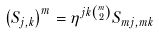Convert formula to latex. <formula><loc_0><loc_0><loc_500><loc_500>\left ( S _ { j , k } \right ) ^ { m } = \eta ^ { j k \binom { m } { 2 } } S _ { m j , m k }</formula> 